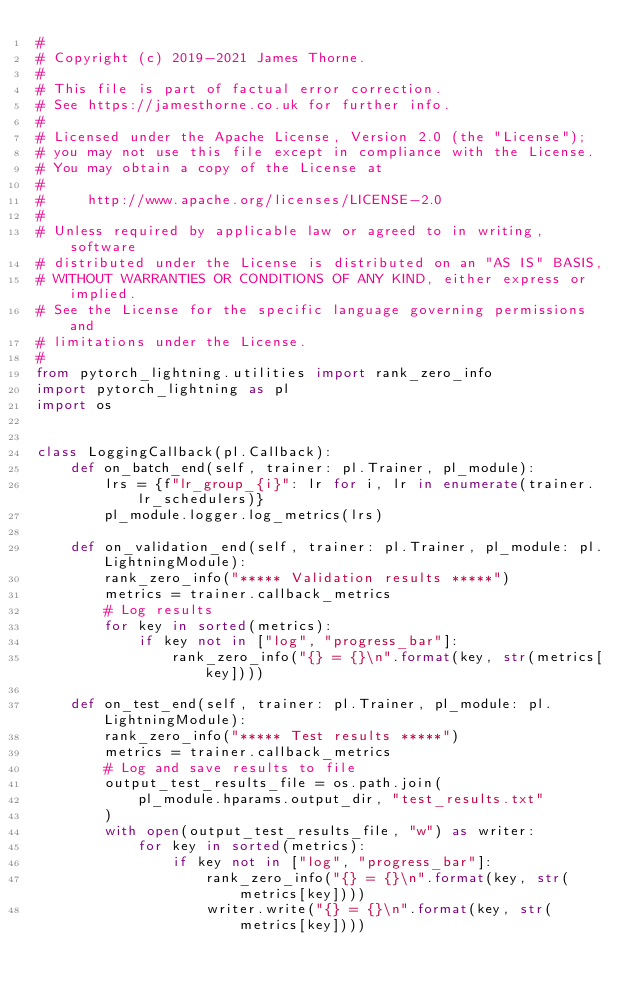Convert code to text. <code><loc_0><loc_0><loc_500><loc_500><_Python_>#
# Copyright (c) 2019-2021 James Thorne.
#
# This file is part of factual error correction.
# See https://jamesthorne.co.uk for further info.
#
# Licensed under the Apache License, Version 2.0 (the "License");
# you may not use this file except in compliance with the License.
# You may obtain a copy of the License at
#
#     http://www.apache.org/licenses/LICENSE-2.0
#
# Unless required by applicable law or agreed to in writing, software
# distributed under the License is distributed on an "AS IS" BASIS,
# WITHOUT WARRANTIES OR CONDITIONS OF ANY KIND, either express or implied.
# See the License for the specific language governing permissions and
# limitations under the License.
#
from pytorch_lightning.utilities import rank_zero_info
import pytorch_lightning as pl
import os


class LoggingCallback(pl.Callback):
    def on_batch_end(self, trainer: pl.Trainer, pl_module):
        lrs = {f"lr_group_{i}": lr for i, lr in enumerate(trainer.lr_schedulers)}
        pl_module.logger.log_metrics(lrs)

    def on_validation_end(self, trainer: pl.Trainer, pl_module: pl.LightningModule):
        rank_zero_info("***** Validation results *****")
        metrics = trainer.callback_metrics
        # Log results
        for key in sorted(metrics):
            if key not in ["log", "progress_bar"]:
                rank_zero_info("{} = {}\n".format(key, str(metrics[key])))

    def on_test_end(self, trainer: pl.Trainer, pl_module: pl.LightningModule):
        rank_zero_info("***** Test results *****")
        metrics = trainer.callback_metrics
        # Log and save results to file
        output_test_results_file = os.path.join(
            pl_module.hparams.output_dir, "test_results.txt"
        )
        with open(output_test_results_file, "w") as writer:
            for key in sorted(metrics):
                if key not in ["log", "progress_bar"]:
                    rank_zero_info("{} = {}\n".format(key, str(metrics[key])))
                    writer.write("{} = {}\n".format(key, str(metrics[key])))
</code> 